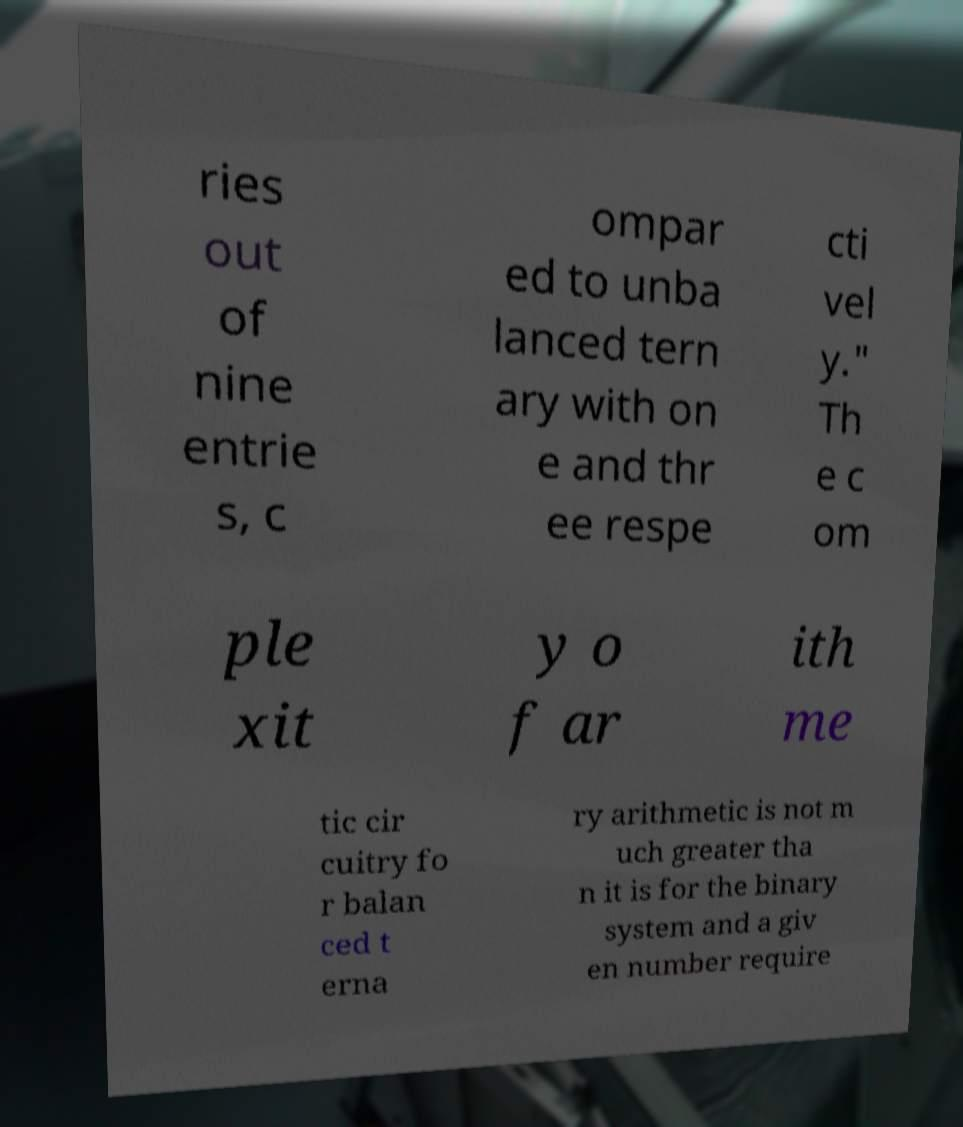Please identify and transcribe the text found in this image. ries out of nine entrie s, c ompar ed to unba lanced tern ary with on e and thr ee respe cti vel y." Th e c om ple xit y o f ar ith me tic cir cuitry fo r balan ced t erna ry arithmetic is not m uch greater tha n it is for the binary system and a giv en number require 